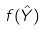<formula> <loc_0><loc_0><loc_500><loc_500>f ( \hat { Y } )</formula> 